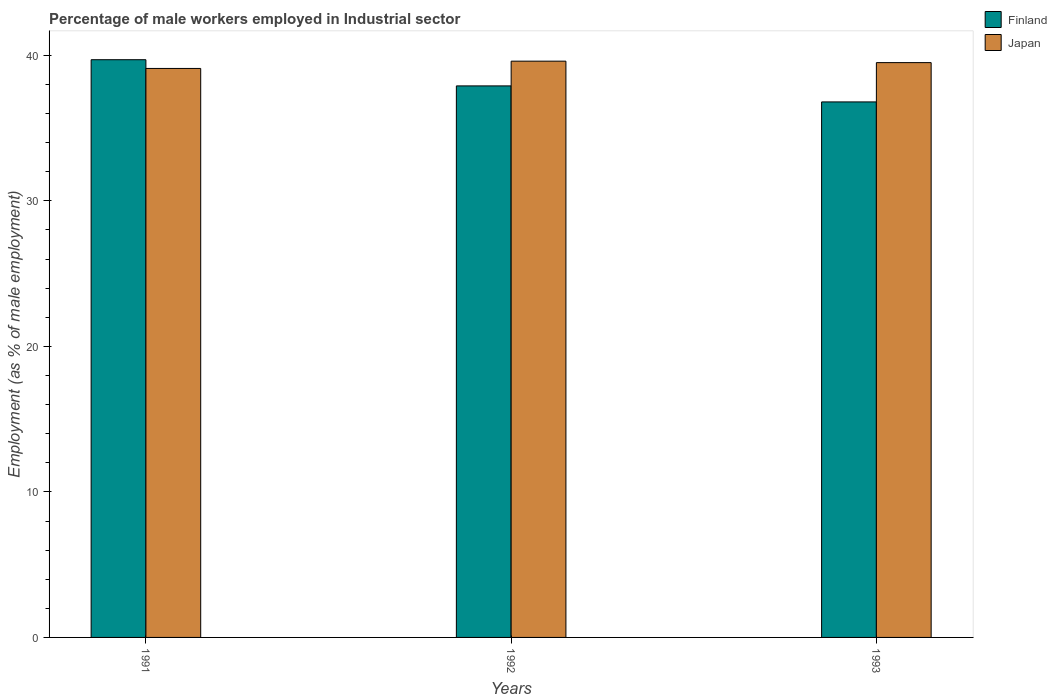How many different coloured bars are there?
Provide a succinct answer. 2. How many groups of bars are there?
Your answer should be compact. 3. Are the number of bars per tick equal to the number of legend labels?
Your response must be concise. Yes. Are the number of bars on each tick of the X-axis equal?
Your answer should be compact. Yes. How many bars are there on the 1st tick from the right?
Provide a succinct answer. 2. What is the label of the 1st group of bars from the left?
Offer a terse response. 1991. In how many cases, is the number of bars for a given year not equal to the number of legend labels?
Offer a terse response. 0. What is the percentage of male workers employed in Industrial sector in Japan in 1992?
Your response must be concise. 39.6. Across all years, what is the maximum percentage of male workers employed in Industrial sector in Finland?
Provide a short and direct response. 39.7. Across all years, what is the minimum percentage of male workers employed in Industrial sector in Finland?
Offer a terse response. 36.8. In which year was the percentage of male workers employed in Industrial sector in Finland maximum?
Offer a very short reply. 1991. What is the total percentage of male workers employed in Industrial sector in Finland in the graph?
Provide a short and direct response. 114.4. What is the difference between the percentage of male workers employed in Industrial sector in Finland in 1991 and that in 1993?
Ensure brevity in your answer.  2.9. What is the difference between the percentage of male workers employed in Industrial sector in Finland in 1992 and the percentage of male workers employed in Industrial sector in Japan in 1993?
Make the answer very short. -1.6. What is the average percentage of male workers employed in Industrial sector in Japan per year?
Provide a succinct answer. 39.4. In the year 1991, what is the difference between the percentage of male workers employed in Industrial sector in Japan and percentage of male workers employed in Industrial sector in Finland?
Offer a very short reply. -0.6. What is the ratio of the percentage of male workers employed in Industrial sector in Finland in 1992 to that in 1993?
Give a very brief answer. 1.03. Is the difference between the percentage of male workers employed in Industrial sector in Japan in 1992 and 1993 greater than the difference between the percentage of male workers employed in Industrial sector in Finland in 1992 and 1993?
Offer a very short reply. No. What is the difference between the highest and the second highest percentage of male workers employed in Industrial sector in Finland?
Your answer should be very brief. 1.8. What is the difference between the highest and the lowest percentage of male workers employed in Industrial sector in Japan?
Offer a terse response. 0.5. Is the sum of the percentage of male workers employed in Industrial sector in Finland in 1991 and 1992 greater than the maximum percentage of male workers employed in Industrial sector in Japan across all years?
Ensure brevity in your answer.  Yes. What does the 1st bar from the right in 1991 represents?
Your response must be concise. Japan. How many bars are there?
Your response must be concise. 6. Are all the bars in the graph horizontal?
Keep it short and to the point. No. How many years are there in the graph?
Offer a very short reply. 3. Does the graph contain any zero values?
Offer a very short reply. No. Where does the legend appear in the graph?
Your answer should be compact. Top right. How many legend labels are there?
Offer a terse response. 2. What is the title of the graph?
Provide a short and direct response. Percentage of male workers employed in Industrial sector. Does "Indonesia" appear as one of the legend labels in the graph?
Offer a terse response. No. What is the label or title of the Y-axis?
Provide a short and direct response. Employment (as % of male employment). What is the Employment (as % of male employment) in Finland in 1991?
Your response must be concise. 39.7. What is the Employment (as % of male employment) in Japan in 1991?
Your answer should be very brief. 39.1. What is the Employment (as % of male employment) in Finland in 1992?
Your response must be concise. 37.9. What is the Employment (as % of male employment) in Japan in 1992?
Your answer should be compact. 39.6. What is the Employment (as % of male employment) in Finland in 1993?
Make the answer very short. 36.8. What is the Employment (as % of male employment) of Japan in 1993?
Give a very brief answer. 39.5. Across all years, what is the maximum Employment (as % of male employment) in Finland?
Your answer should be very brief. 39.7. Across all years, what is the maximum Employment (as % of male employment) of Japan?
Your answer should be compact. 39.6. Across all years, what is the minimum Employment (as % of male employment) in Finland?
Your answer should be compact. 36.8. Across all years, what is the minimum Employment (as % of male employment) of Japan?
Your response must be concise. 39.1. What is the total Employment (as % of male employment) in Finland in the graph?
Provide a succinct answer. 114.4. What is the total Employment (as % of male employment) of Japan in the graph?
Provide a succinct answer. 118.2. What is the difference between the Employment (as % of male employment) in Finland in 1991 and that in 1992?
Keep it short and to the point. 1.8. What is the difference between the Employment (as % of male employment) in Finland in 1991 and that in 1993?
Provide a succinct answer. 2.9. What is the difference between the Employment (as % of male employment) in Finland in 1991 and the Employment (as % of male employment) in Japan in 1992?
Offer a very short reply. 0.1. What is the difference between the Employment (as % of male employment) of Finland in 1991 and the Employment (as % of male employment) of Japan in 1993?
Ensure brevity in your answer.  0.2. What is the average Employment (as % of male employment) in Finland per year?
Your answer should be very brief. 38.13. What is the average Employment (as % of male employment) of Japan per year?
Offer a very short reply. 39.4. In the year 1991, what is the difference between the Employment (as % of male employment) of Finland and Employment (as % of male employment) of Japan?
Your answer should be very brief. 0.6. In the year 1992, what is the difference between the Employment (as % of male employment) of Finland and Employment (as % of male employment) of Japan?
Provide a succinct answer. -1.7. In the year 1993, what is the difference between the Employment (as % of male employment) of Finland and Employment (as % of male employment) of Japan?
Offer a very short reply. -2.7. What is the ratio of the Employment (as % of male employment) of Finland in 1991 to that in 1992?
Provide a succinct answer. 1.05. What is the ratio of the Employment (as % of male employment) in Japan in 1991 to that in 1992?
Give a very brief answer. 0.99. What is the ratio of the Employment (as % of male employment) of Finland in 1991 to that in 1993?
Offer a terse response. 1.08. What is the ratio of the Employment (as % of male employment) in Japan in 1991 to that in 1993?
Offer a terse response. 0.99. What is the ratio of the Employment (as % of male employment) of Finland in 1992 to that in 1993?
Ensure brevity in your answer.  1.03. What is the ratio of the Employment (as % of male employment) of Japan in 1992 to that in 1993?
Your answer should be compact. 1. What is the difference between the highest and the second highest Employment (as % of male employment) of Finland?
Offer a very short reply. 1.8. What is the difference between the highest and the second highest Employment (as % of male employment) of Japan?
Keep it short and to the point. 0.1. What is the difference between the highest and the lowest Employment (as % of male employment) of Finland?
Offer a very short reply. 2.9. 